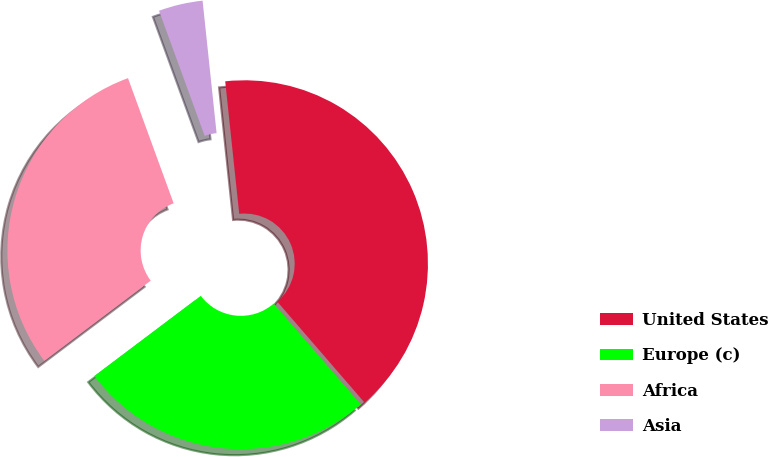Convert chart to OTSL. <chart><loc_0><loc_0><loc_500><loc_500><pie_chart><fcel>United States<fcel>Europe (c)<fcel>Africa<fcel>Asia<nl><fcel>40.33%<fcel>26.07%<fcel>29.71%<fcel>3.89%<nl></chart> 